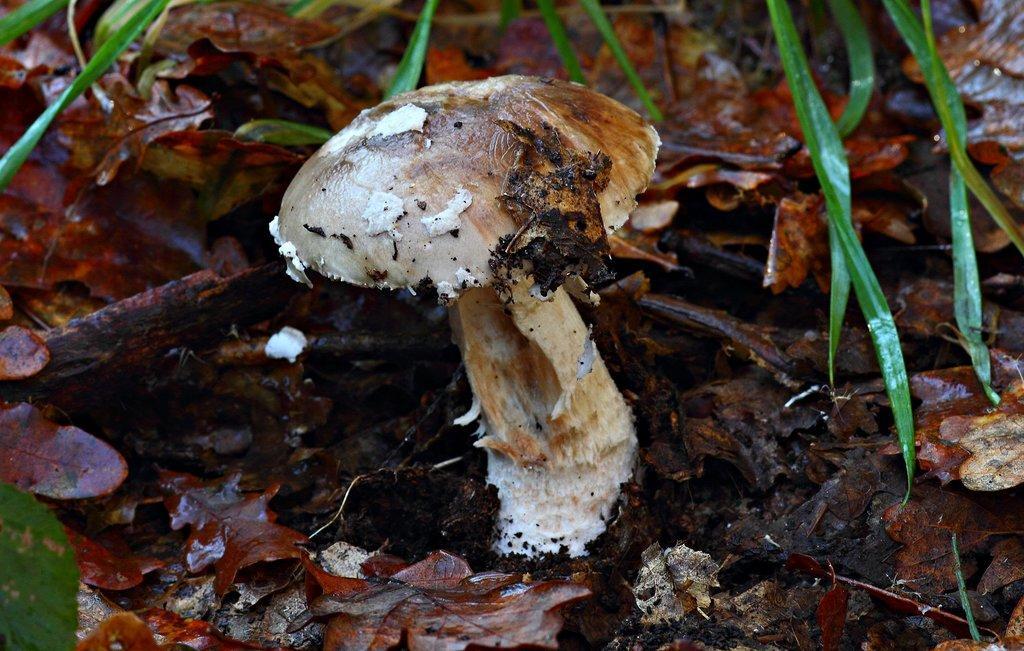Describe this image in one or two sentences. In this image, this looks like a mushroom. These are the dried leaves. I think this is a grass. 